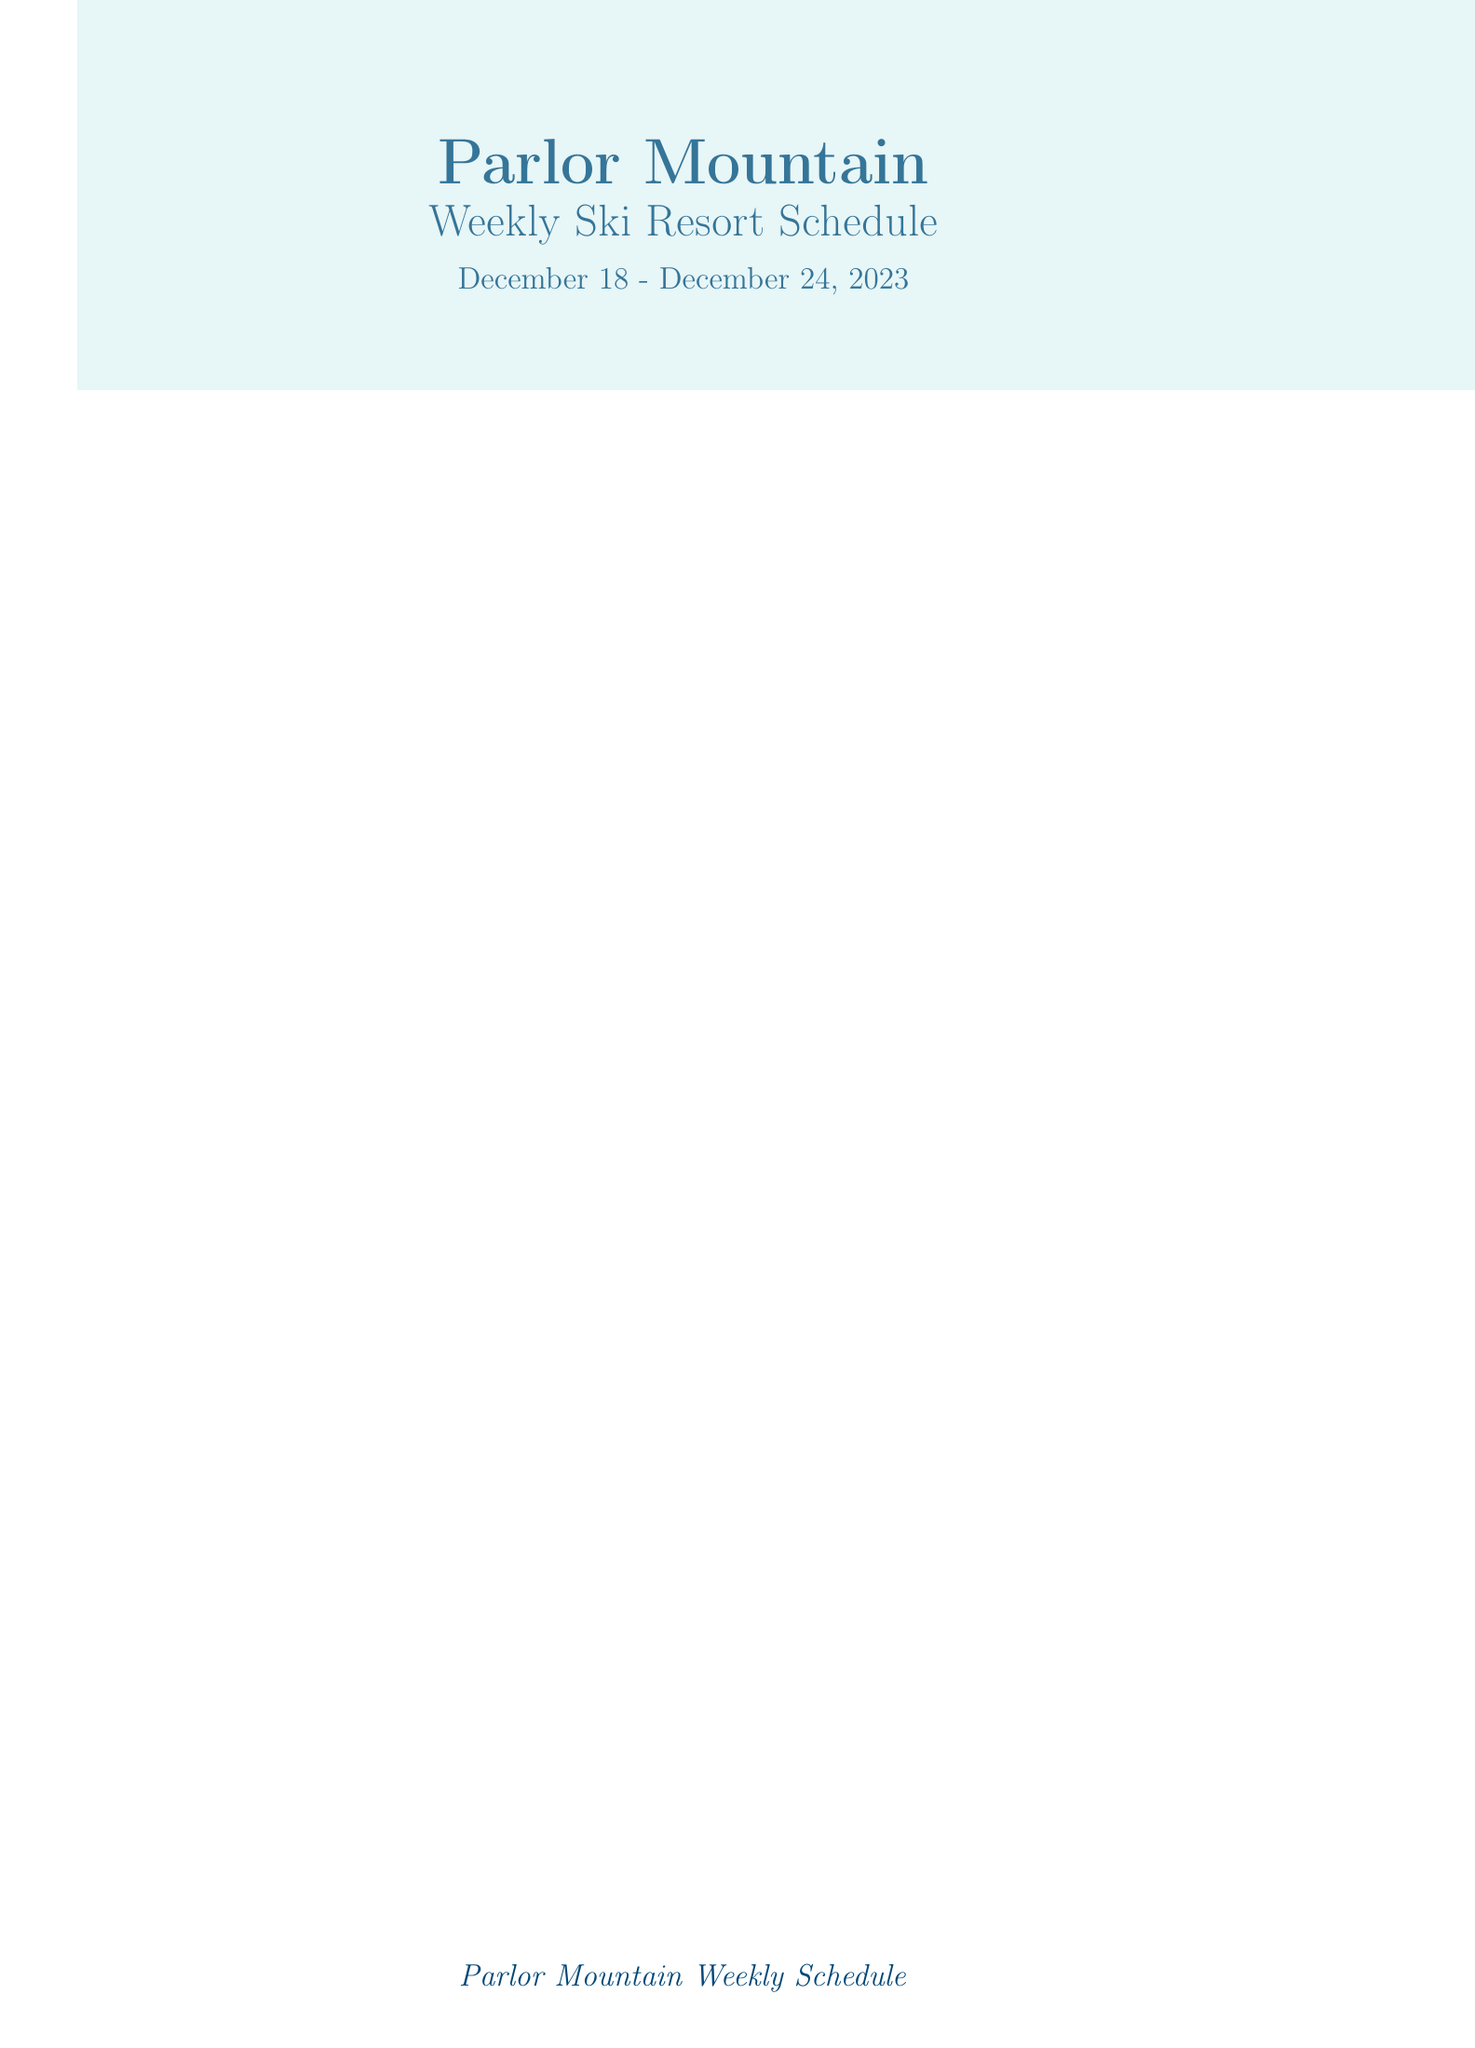What are the lift hours for Beginner's Delight on Friday? The lift hours for Beginner's Delight on Friday are specifically listed in the document.
Answer: 9:30 AM - 4:00 PM How many groomed runs are available on Wednesday? The number of groomed runs for Wednesday is directly stated in the snow conditions section.
Answer: 22 What special event is happening on Thursday? The document mentions the special event scheduled for Thursday specifically.
Answer: Winter Solstice Celebration What was the base depth of snow on Saturday? The document provides the base depth for snow on Saturday under snow conditions.
Answer: 63 How much new snow was reported on Monday? The amount of new snow on Monday can be found in the snow conditions specified for that date.
Answer: 3 inches What time does the Night Owl lift operate on Wednesday? The document lists the operating hours for the Night Owl lift on Wednesday in the lift hours.
Answer: 5:00 PM - 9:00 PM Is the free shuttle service available every hour? The transportation section highlights the frequency of the free shuttle service.
Answer: every 30 minutes What is the total new snow for the week? You can calculate the total new snow by summing the new snow amounts listed for each day in the schedule.
Answer: 26 inches Which accommodations are mentioned nearby? The list of nearby accommodations is provided in the additional information section.
Answer: Parlor Mountain Lodge, Snowflake Inn, Alpine Chalets 